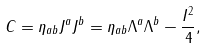Convert formula to latex. <formula><loc_0><loc_0><loc_500><loc_500>C = \eta _ { a b } J ^ { a } J ^ { b } = \eta _ { a b } \Lambda ^ { a } \Lambda ^ { b } - \frac { I ^ { 2 } } { 4 } ,</formula> 